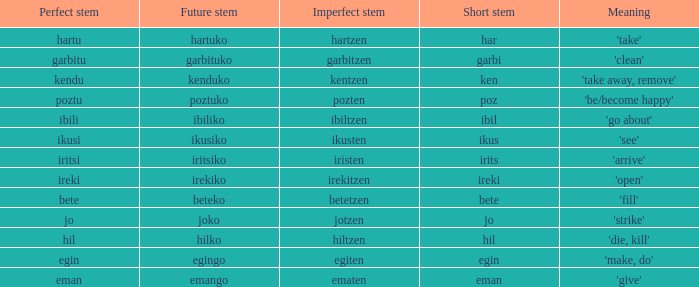What is the digit for future stem for poztu? 1.0. 